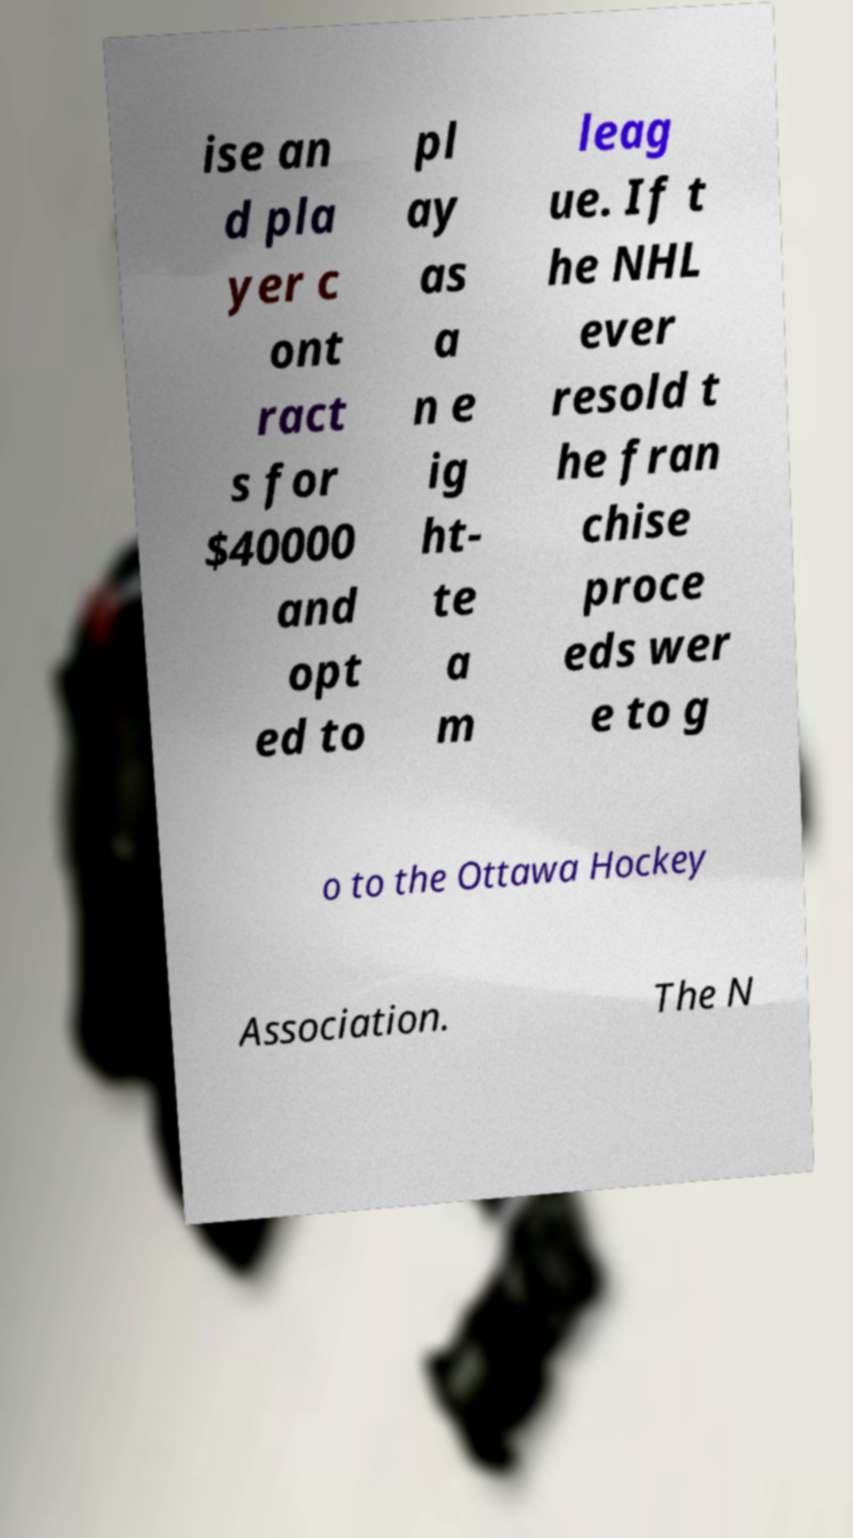What messages or text are displayed in this image? I need them in a readable, typed format. ise an d pla yer c ont ract s for $40000 and opt ed to pl ay as a n e ig ht- te a m leag ue. If t he NHL ever resold t he fran chise proce eds wer e to g o to the Ottawa Hockey Association. The N 